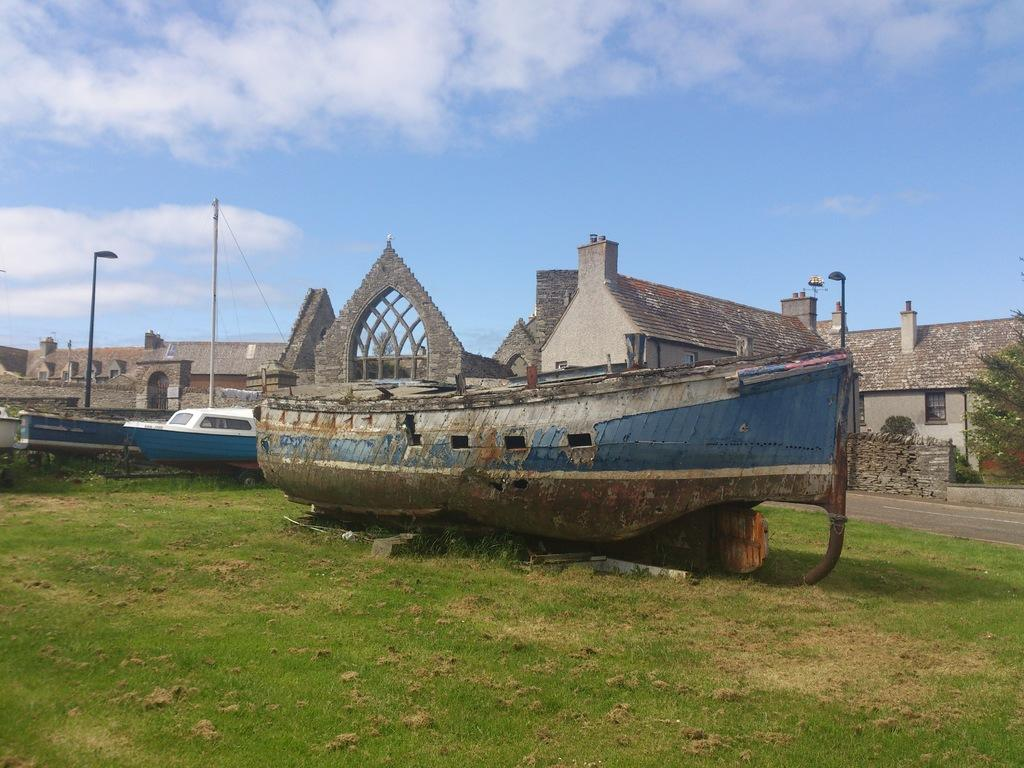What objects are placed on the ground in the image? There are boats placed on the ground in the image. What type of terrain is visible in the image? There is grass visible in the image. What structures can be seen in the image? There are buildings in the image. What type of vegetation is present in the image? Plants and a tree are present in the image. What is visible in the sky in the image? The sky is visible in the image, and it appears cloudy. Can you tell me how many toes are visible on the tree in the image? There are no toes visible in the image, as trees do not have toes. What type of group is shown interacting with the boats in the image? There is no group of people interacting with the boats in the image; the boats are simply placed on the ground. 